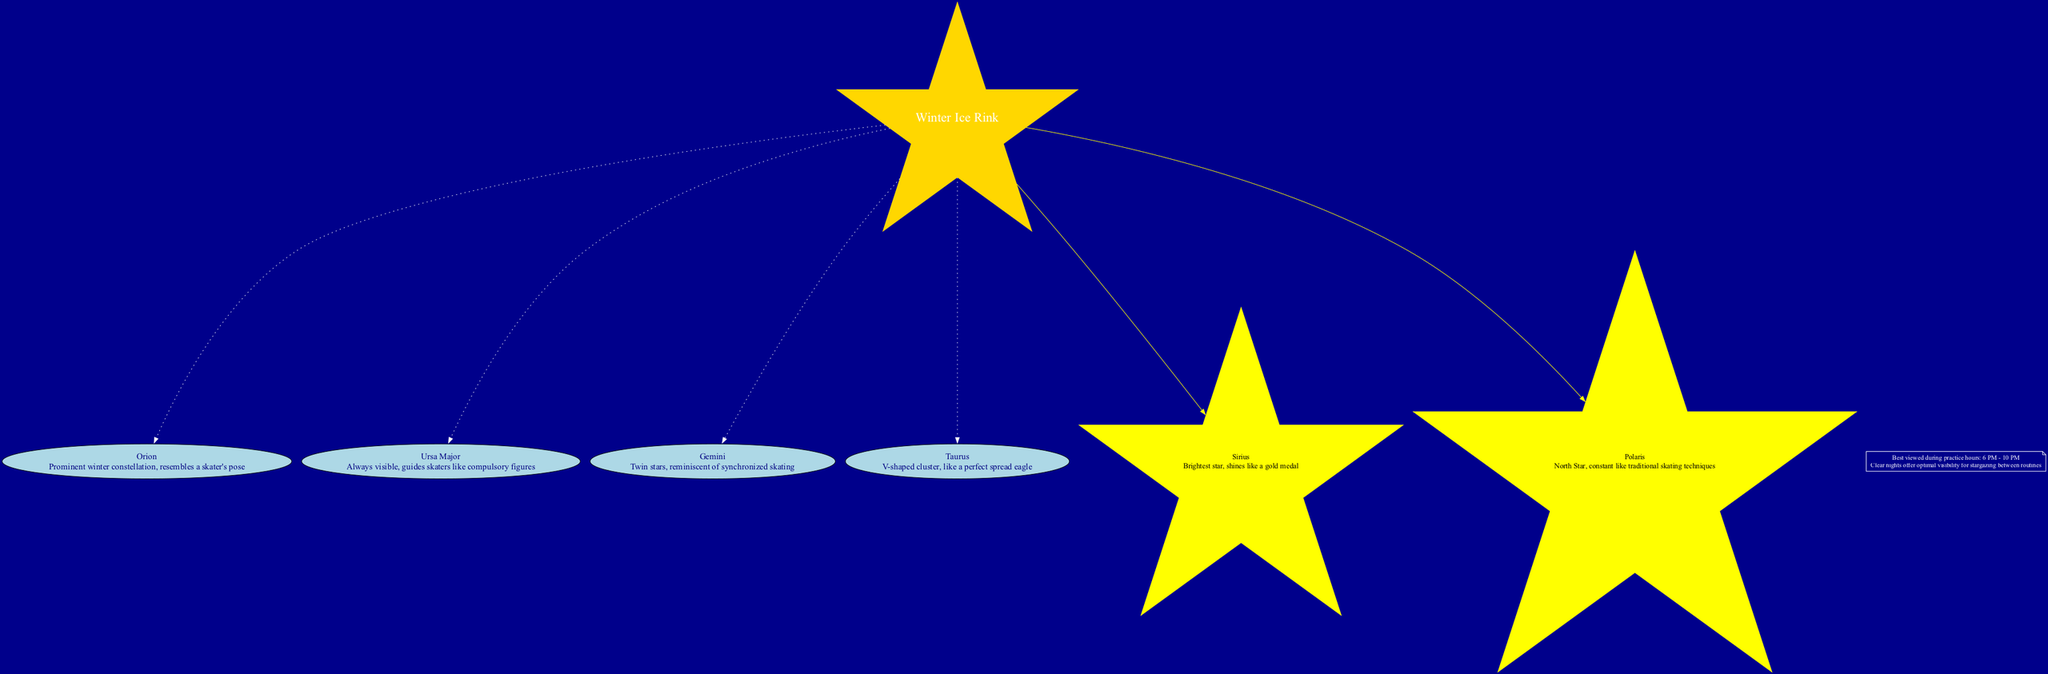What is the center node of the diagram? The center node of the diagram is "Winter Ice Rink". It is explicitly labeled in the diagram as the main focal point from which constellations and stars are connected.
Answer: Winter Ice Rink How many constellations are displayed in the diagram? There are four constellations listed under the constellation nodes: Orion, Ursa Major, Gemini, and Taurus. Counting these nodes provides the answer.
Answer: 4 Which constellation is described as resembling a skater's pose? The constellation described as resembling a skater's pose is Orion. The description mentioned aligns it visually with a skating position, making it identifiable from the diagram.
Answer: Orion What star is the brightest in the winter sky as per the diagram? The brightest star indicated in the diagram is Sirius. It is noted in the stars section, highlighting its brightness compared to others.
Answer: Sirius Which constellation is associated with synchronized skating? The constellation associated with synchronized skating is Gemini. The description connects this constellation with the concept of "twins," which is analogous to synchronized movements in skating.
Answer: Gemini What is the optimal viewing time range for stargazing mentioned in the notes? The optimal viewing time range for stargazing, as noted in the diagram, is between 6 PM and 10 PM. This range is specifically pointed out for best visibility while practicing.
Answer: 6 PM - 10 PM What star is referred to as the North Star in the diagram? The North Star mentioned in the diagram is Polaris. It’s labeled as a guide point, which can be seen from the center of the ice rink in the context of the diagram.
Answer: Polaris What shape is the cluster representing Taurus? The cluster representing Taurus is described as V-shaped. This description visually signifies a specific formation that can be recognized from the diagram.
Answer: V-shaped How do the constellations relate to the center node? All four constellations are directly connected to the center node, "Winter Ice Rink," through dotted edges, indicating they are part of the depicted winter sky view from that central point.
Answer: Directly connected 